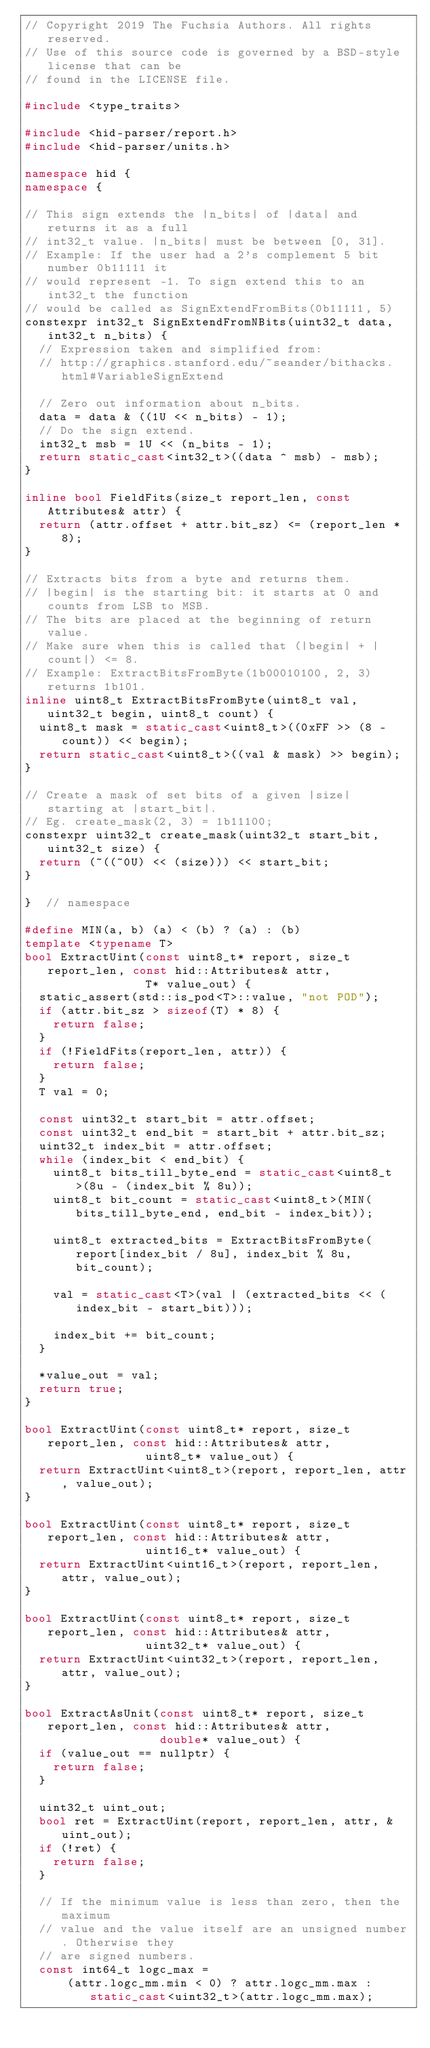<code> <loc_0><loc_0><loc_500><loc_500><_C++_>// Copyright 2019 The Fuchsia Authors. All rights reserved.
// Use of this source code is governed by a BSD-style license that can be
// found in the LICENSE file.

#include <type_traits>

#include <hid-parser/report.h>
#include <hid-parser/units.h>

namespace hid {
namespace {

// This sign extends the |n_bits| of |data| and returns it as a full
// int32_t value. |n_bits| must be between [0, 31].
// Example: If the user had a 2's complement 5 bit number 0b11111 it
// would represent -1. To sign extend this to an int32_t the function
// would be called as SignExtendFromBits(0b11111, 5)
constexpr int32_t SignExtendFromNBits(uint32_t data, int32_t n_bits) {
  // Expression taken and simplified from:
  // http://graphics.stanford.edu/~seander/bithacks.html#VariableSignExtend

  // Zero out information about n_bits.
  data = data & ((1U << n_bits) - 1);
  // Do the sign extend.
  int32_t msb = 1U << (n_bits - 1);
  return static_cast<int32_t>((data ^ msb) - msb);
}

inline bool FieldFits(size_t report_len, const Attributes& attr) {
  return (attr.offset + attr.bit_sz) <= (report_len * 8);
}

// Extracts bits from a byte and returns them.
// |begin| is the starting bit: it starts at 0 and counts from LSB to MSB.
// The bits are placed at the beginning of return value.
// Make sure when this is called that (|begin| + |count|) <= 8.
// Example: ExtractBitsFromByte(1b00010100, 2, 3) returns 1b101.
inline uint8_t ExtractBitsFromByte(uint8_t val, uint32_t begin, uint8_t count) {
  uint8_t mask = static_cast<uint8_t>((0xFF >> (8 - count)) << begin);
  return static_cast<uint8_t>((val & mask) >> begin);
}

// Create a mask of set bits of a given |size| starting at |start_bit|.
// Eg. create_mask(2, 3) = 1b11100;
constexpr uint32_t create_mask(uint32_t start_bit, uint32_t size) {
  return (~((~0U) << (size))) << start_bit;
}

}  // namespace

#define MIN(a, b) (a) < (b) ? (a) : (b)
template <typename T>
bool ExtractUint(const uint8_t* report, size_t report_len, const hid::Attributes& attr,
                 T* value_out) {
  static_assert(std::is_pod<T>::value, "not POD");
  if (attr.bit_sz > sizeof(T) * 8) {
    return false;
  }
  if (!FieldFits(report_len, attr)) {
    return false;
  }
  T val = 0;

  const uint32_t start_bit = attr.offset;
  const uint32_t end_bit = start_bit + attr.bit_sz;
  uint32_t index_bit = attr.offset;
  while (index_bit < end_bit) {
    uint8_t bits_till_byte_end = static_cast<uint8_t>(8u - (index_bit % 8u));
    uint8_t bit_count = static_cast<uint8_t>(MIN(bits_till_byte_end, end_bit - index_bit));

    uint8_t extracted_bits = ExtractBitsFromByte(report[index_bit / 8u], index_bit % 8u, bit_count);

    val = static_cast<T>(val | (extracted_bits << (index_bit - start_bit)));

    index_bit += bit_count;
  }

  *value_out = val;
  return true;
}

bool ExtractUint(const uint8_t* report, size_t report_len, const hid::Attributes& attr,
                 uint8_t* value_out) {
  return ExtractUint<uint8_t>(report, report_len, attr, value_out);
}

bool ExtractUint(const uint8_t* report, size_t report_len, const hid::Attributes& attr,
                 uint16_t* value_out) {
  return ExtractUint<uint16_t>(report, report_len, attr, value_out);
}

bool ExtractUint(const uint8_t* report, size_t report_len, const hid::Attributes& attr,
                 uint32_t* value_out) {
  return ExtractUint<uint32_t>(report, report_len, attr, value_out);
}

bool ExtractAsUnit(const uint8_t* report, size_t report_len, const hid::Attributes& attr,
                   double* value_out) {
  if (value_out == nullptr) {
    return false;
  }

  uint32_t uint_out;
  bool ret = ExtractUint(report, report_len, attr, &uint_out);
  if (!ret) {
    return false;
  }

  // If the minimum value is less than zero, then the maximum
  // value and the value itself are an unsigned number. Otherwise they
  // are signed numbers.
  const int64_t logc_max =
      (attr.logc_mm.min < 0) ? attr.logc_mm.max : static_cast<uint32_t>(attr.logc_mm.max);</code> 